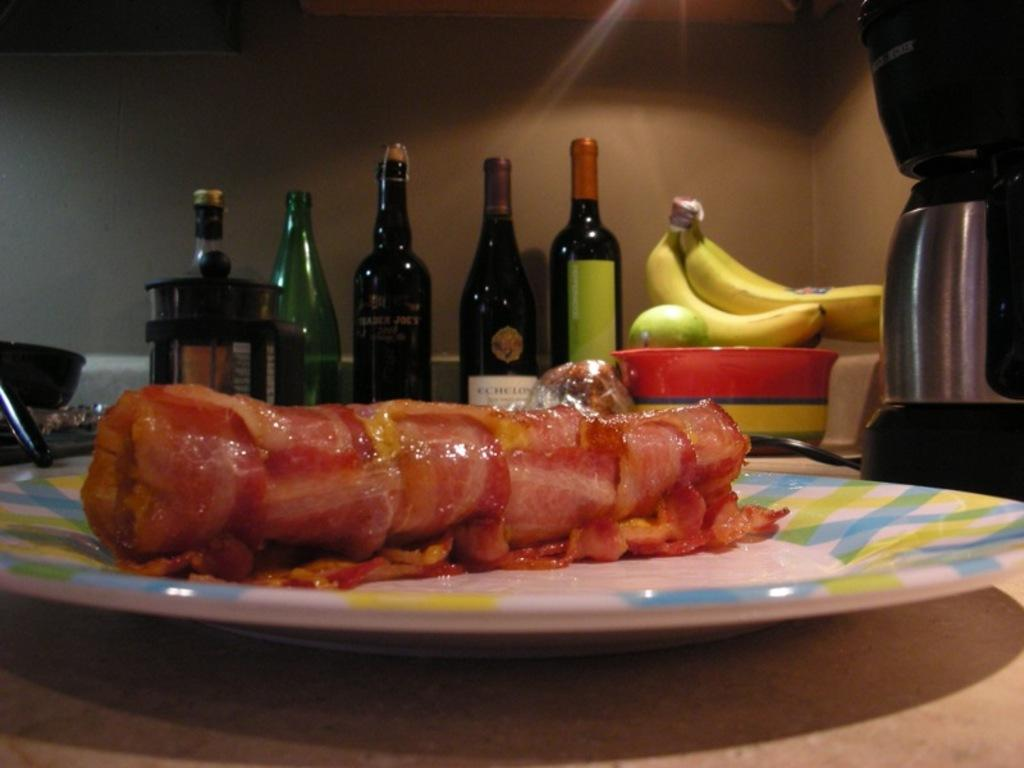What objects are present in the image that are typically used for holding liquids? There are bottles in the image. What type of fruit can be seen in the image? There is a banana in the image. What is the main food item visible in the image? There is food in a plate in the image. What type of discussion is taking place in the image? There is no discussion present in the image; it features bottles, a banana, and food in a plate. What type of sack is visible in the image? There is no sack present in the image. 